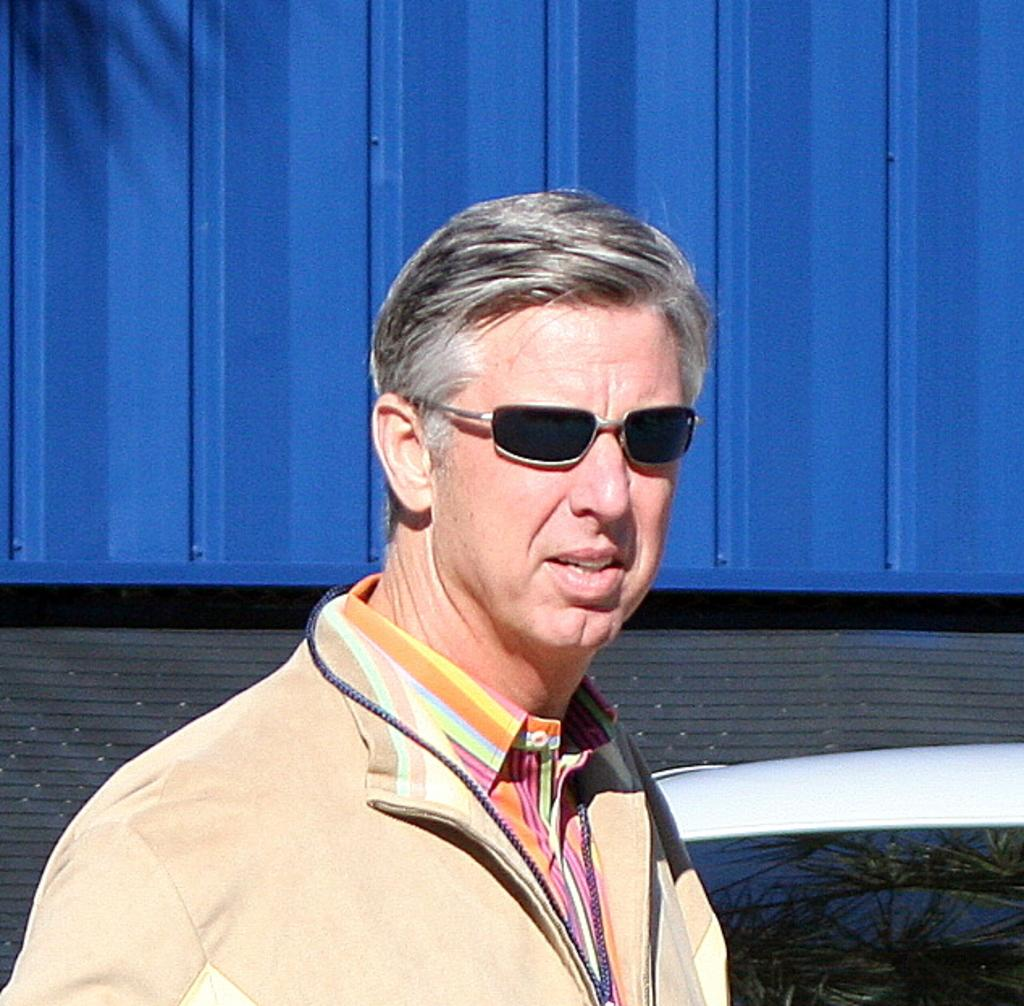Who is present in the image? There is a man in the image. What is the man wearing in the image? The man is wearing sunglasses. What can be seen in the background of the image? There is a car and a metal container in the background of the image. What type of eye is visible on the car in the image? There is no eye visible on the car in the image. The car is a vehicle and does not have eyes. 